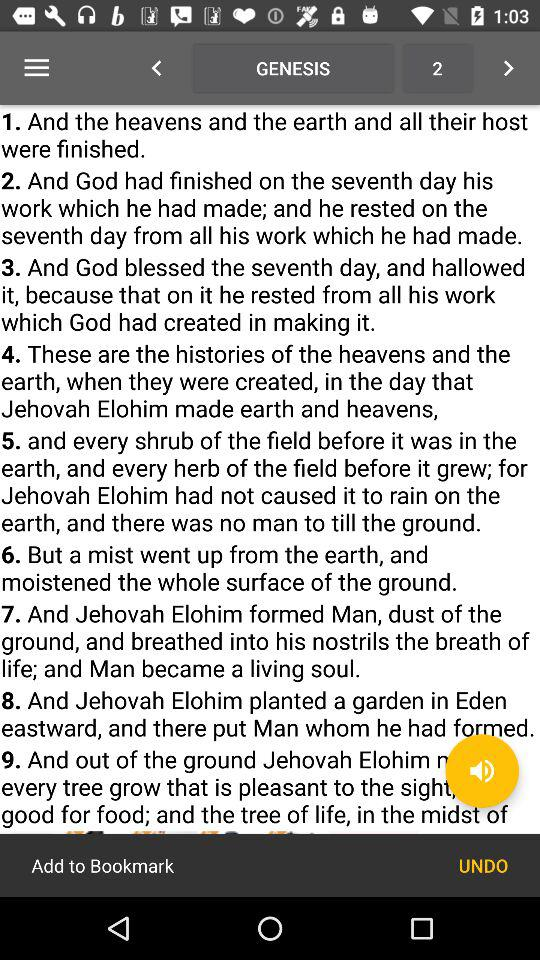Who formed man? Man was formed by Jehovah Elohim. 